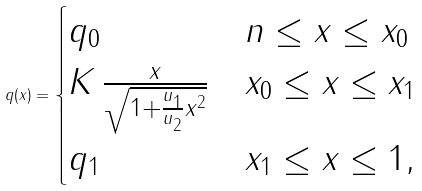Convert formula to latex. <formula><loc_0><loc_0><loc_500><loc_500>q ( x ) = \begin{cases} q _ { 0 } & n \leq x \leq x _ { 0 } \\ K \, \frac { x } { \sqrt { 1 + \frac { u _ { 1 } } { u _ { 2 } } x ^ { 2 } } } & x _ { 0 } \leq x \leq x _ { 1 } \\ q _ { 1 } & x _ { 1 } \leq x \leq 1 , \end{cases}</formula> 